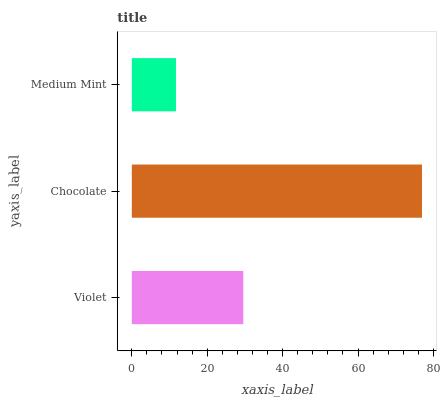Is Medium Mint the minimum?
Answer yes or no. Yes. Is Chocolate the maximum?
Answer yes or no. Yes. Is Chocolate the minimum?
Answer yes or no. No. Is Medium Mint the maximum?
Answer yes or no. No. Is Chocolate greater than Medium Mint?
Answer yes or no. Yes. Is Medium Mint less than Chocolate?
Answer yes or no. Yes. Is Medium Mint greater than Chocolate?
Answer yes or no. No. Is Chocolate less than Medium Mint?
Answer yes or no. No. Is Violet the high median?
Answer yes or no. Yes. Is Violet the low median?
Answer yes or no. Yes. Is Chocolate the high median?
Answer yes or no. No. Is Medium Mint the low median?
Answer yes or no. No. 